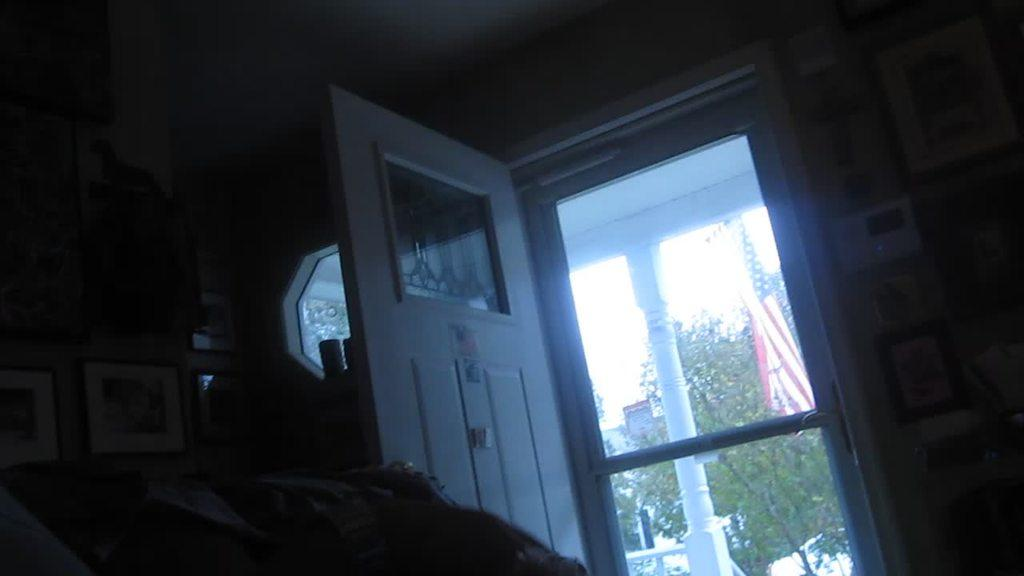What is one of the main architectural features in the image? There is a door in the image. What can be seen on the wall in the image? There are photo frames on the wall. What part of the room is visible in the image? There is a ceiling visible in the image. What can be seen in the background of the image? There are trees, a flag, and buildings in the background of the image. How many teeth can be seen in the image? There are no teeth visible in the image. What type of shoes are the trees wearing in the image? Trees do not wear shoes, as they are not human or animal. 